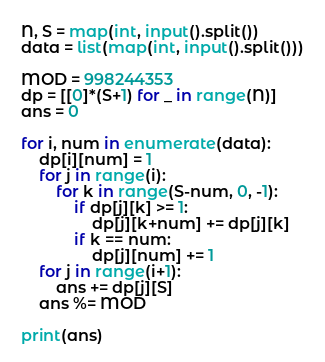Convert code to text. <code><loc_0><loc_0><loc_500><loc_500><_Python_>N, S = map(int, input().split())
data = list(map(int, input().split()))

MOD = 998244353
dp = [[0]*(S+1) for _ in range(N)]
ans = 0

for i, num in enumerate(data):
    dp[i][num] = 1
    for j in range(i):
        for k in range(S-num, 0, -1):
            if dp[j][k] >= 1:
                dp[j][k+num] += dp[j][k]
            if k == num:
                dp[j][num] += 1
    for j in range(i+1):
        ans += dp[j][S]
    ans %= MOD

print(ans)</code> 